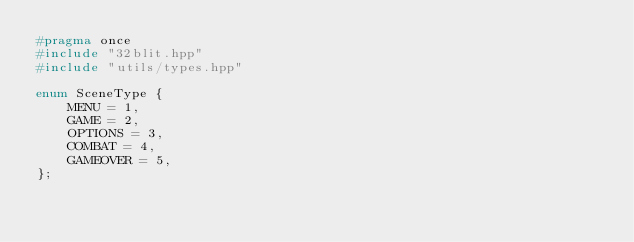Convert code to text. <code><loc_0><loc_0><loc_500><loc_500><_C++_>#pragma once
#include "32blit.hpp"
#include "utils/types.hpp"

enum SceneType {
	MENU = 1,
	GAME = 2,
	OPTIONS = 3,
	COMBAT = 4,
	GAMEOVER = 5,
};
</code> 